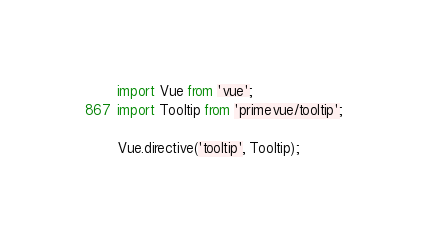<code> <loc_0><loc_0><loc_500><loc_500><_JavaScript_>import Vue from 'vue';
import Tooltip from 'primevue/tooltip';

Vue.directive('tooltip', Tooltip);</code> 